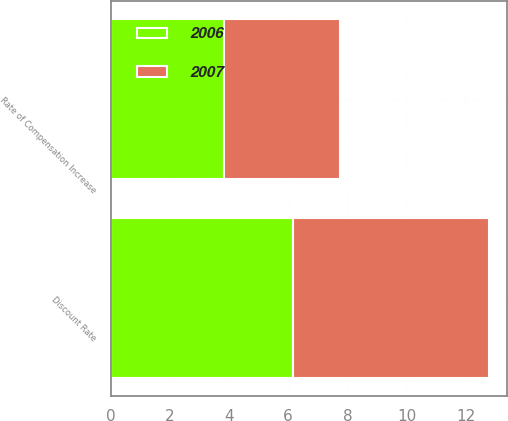Convert chart to OTSL. <chart><loc_0><loc_0><loc_500><loc_500><stacked_bar_chart><ecel><fcel>Discount Rate<fcel>Rate of Compensation Increase<nl><fcel>2007<fcel>6.62<fcel>3.91<nl><fcel>2006<fcel>6.15<fcel>3.85<nl></chart> 